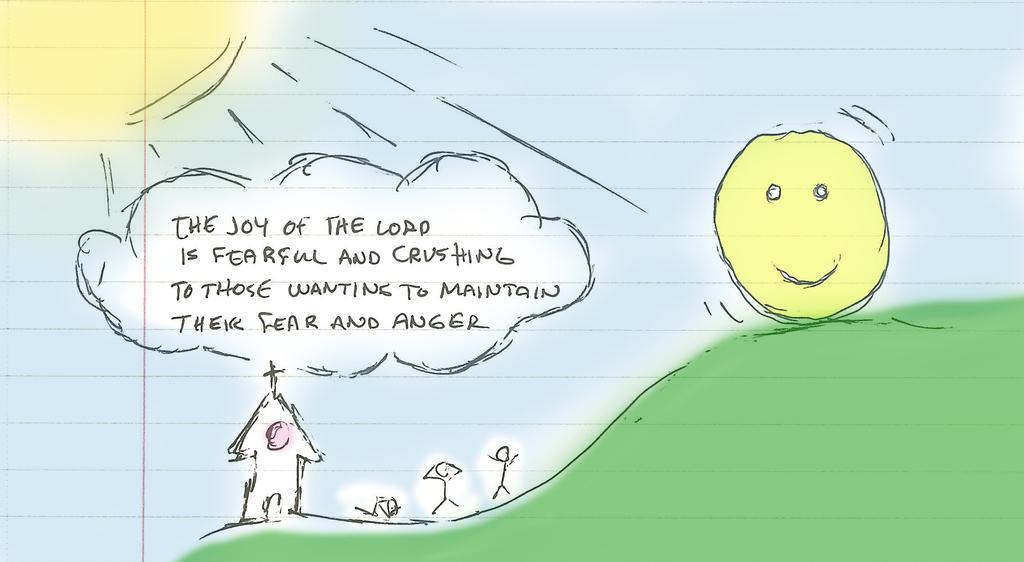In one or two sentences, can you explain what this image depicts? In this picture we can see a paper, there is a painting on the paper, we can see handwritten text in the middle. 